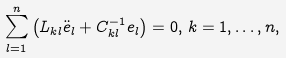<formula> <loc_0><loc_0><loc_500><loc_500>\sum _ { l = 1 } ^ { n } \left ( L _ { k l } \ddot { e } _ { l } + C ^ { - 1 } _ { k l } e _ { l } \right ) = 0 , \, k = 1 , \dots , n ,</formula> 